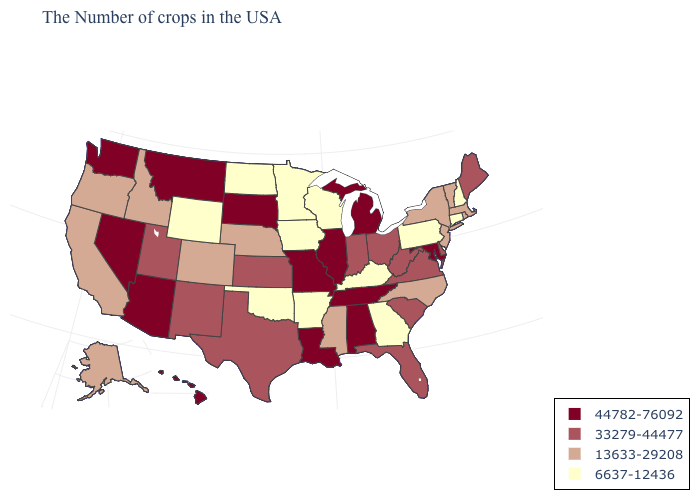Among the states that border Wisconsin , does Minnesota have the lowest value?
Write a very short answer. Yes. What is the value of Mississippi?
Be succinct. 13633-29208. Among the states that border Massachusetts , does Connecticut have the highest value?
Give a very brief answer. No. Does Minnesota have the lowest value in the MidWest?
Keep it brief. Yes. Name the states that have a value in the range 13633-29208?
Short answer required. Massachusetts, Rhode Island, Vermont, New York, New Jersey, North Carolina, Mississippi, Nebraska, Colorado, Idaho, California, Oregon, Alaska. Does Michigan have the highest value in the MidWest?
Give a very brief answer. Yes. What is the value of Montana?
Be succinct. 44782-76092. Name the states that have a value in the range 44782-76092?
Short answer required. Maryland, Michigan, Alabama, Tennessee, Illinois, Louisiana, Missouri, South Dakota, Montana, Arizona, Nevada, Washington, Hawaii. Does Michigan have the highest value in the USA?
Concise answer only. Yes. Name the states that have a value in the range 6637-12436?
Give a very brief answer. New Hampshire, Connecticut, Pennsylvania, Georgia, Kentucky, Wisconsin, Arkansas, Minnesota, Iowa, Oklahoma, North Dakota, Wyoming. What is the value of Oklahoma?
Short answer required. 6637-12436. What is the value of New Hampshire?
Write a very short answer. 6637-12436. Among the states that border Oklahoma , which have the lowest value?
Short answer required. Arkansas. Does New Hampshire have the lowest value in the USA?
Concise answer only. Yes. Name the states that have a value in the range 44782-76092?
Answer briefly. Maryland, Michigan, Alabama, Tennessee, Illinois, Louisiana, Missouri, South Dakota, Montana, Arizona, Nevada, Washington, Hawaii. 